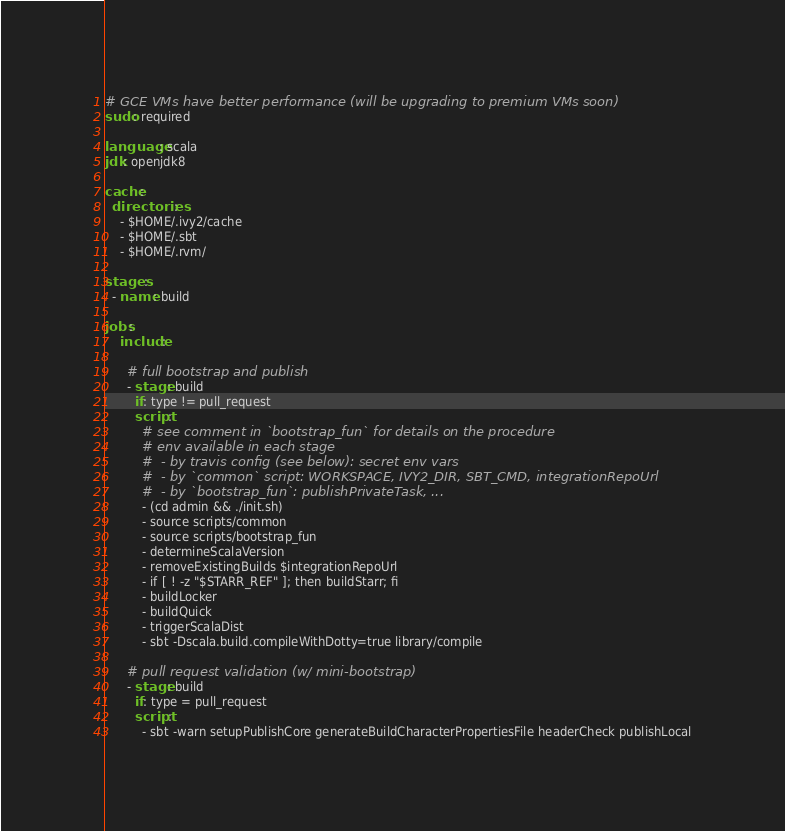<code> <loc_0><loc_0><loc_500><loc_500><_YAML_># GCE VMs have better performance (will be upgrading to premium VMs soon)
sudo: required

language: scala
jdk: openjdk8

cache:
  directories:
    - $HOME/.ivy2/cache
    - $HOME/.sbt
    - $HOME/.rvm/

stages:
  - name: build

jobs:
    include:

      # full bootstrap and publish
      - stage: build
        if: type != pull_request
        script:
          # see comment in `bootstrap_fun` for details on the procedure
          # env available in each stage
          #  - by travis config (see below): secret env vars
          #  - by `common` script: WORKSPACE, IVY2_DIR, SBT_CMD, integrationRepoUrl
          #  - by `bootstrap_fun`: publishPrivateTask, ...
          - (cd admin && ./init.sh)
          - source scripts/common
          - source scripts/bootstrap_fun
          - determineScalaVersion
          - removeExistingBuilds $integrationRepoUrl
          - if [ ! -z "$STARR_REF" ]; then buildStarr; fi
          - buildLocker
          - buildQuick
          - triggerScalaDist
          - sbt -Dscala.build.compileWithDotty=true library/compile

      # pull request validation (w/ mini-bootstrap)
      - stage: build
        if: type = pull_request
        script:
          - sbt -warn setupPublishCore generateBuildCharacterPropertiesFile headerCheck publishLocal</code> 